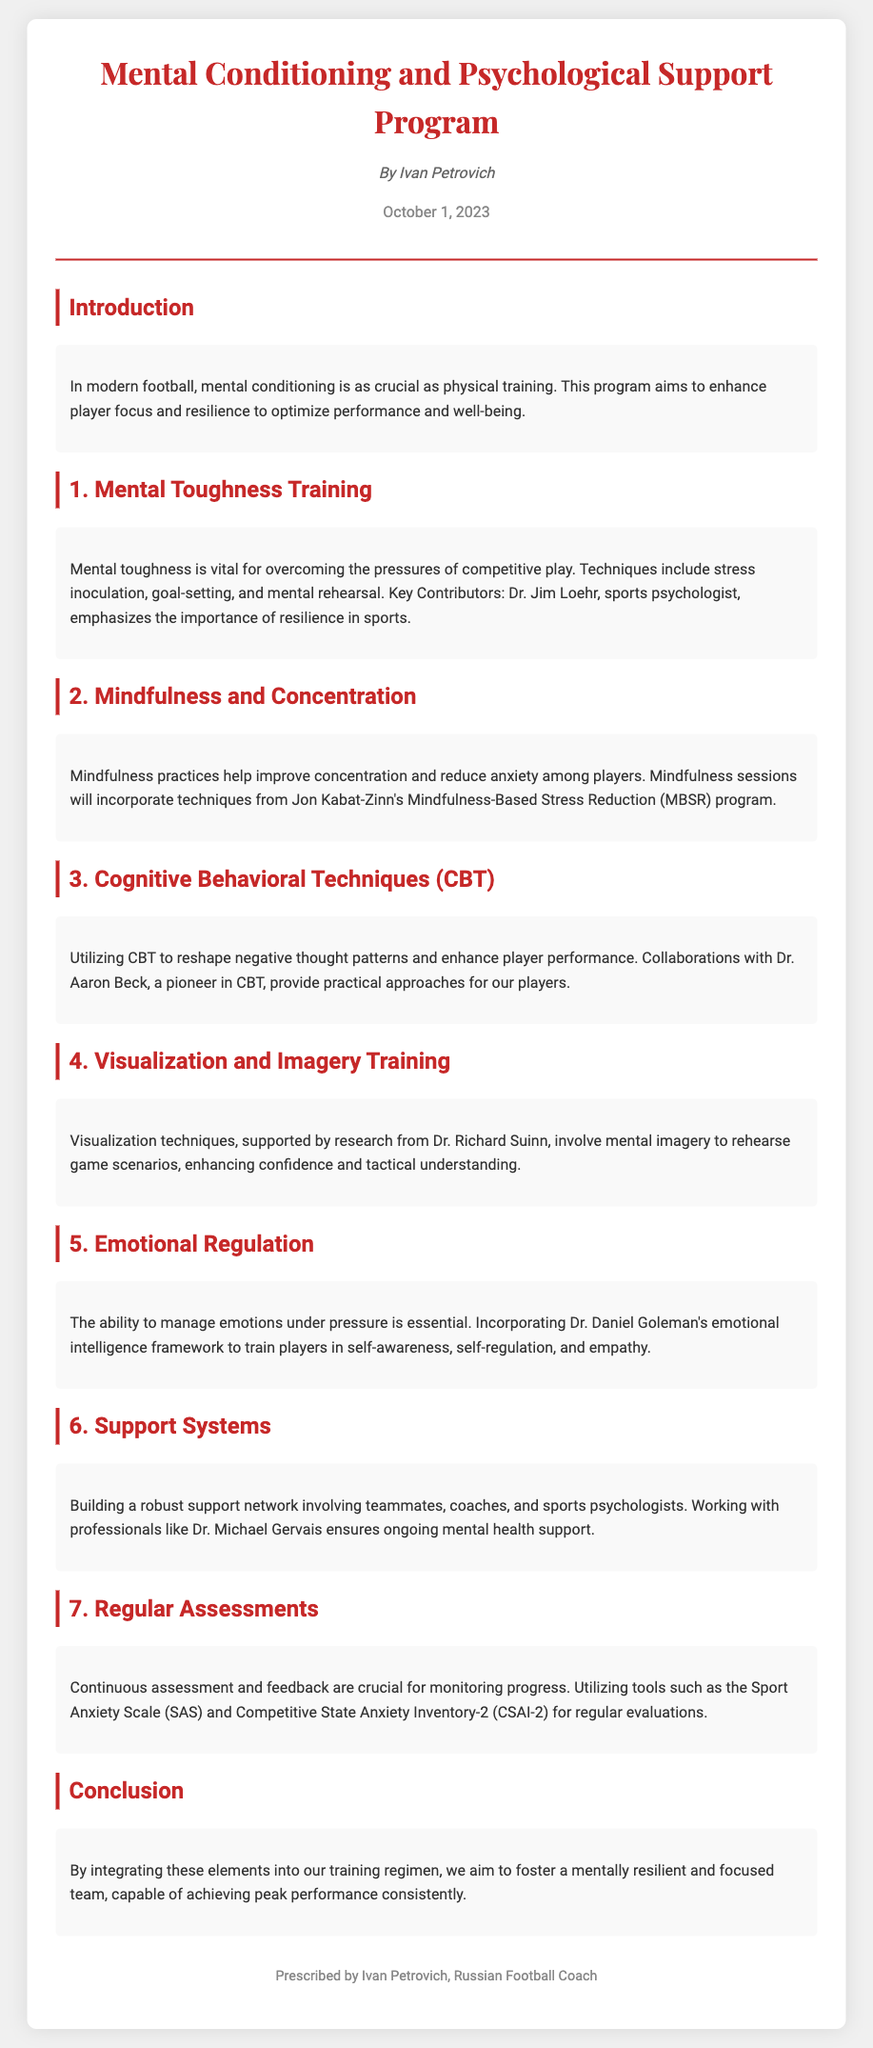what is the title of the program? The title of the program is mentioned at the top of the document.
Answer: Mental Conditioning and Psychological Support Program who is the author of the program? The author of the program is listed below the title.
Answer: Ivan Petrovich when was the program published? The date of publication is provided at the end of the author information.
Answer: October 1, 2023 what technique is included in the Mental Toughness Training section? The document specifies several techniques in the Mental Toughness Training section.
Answer: stress inoculation which framework is used for Emotional Regulation? The document references a specific framework related to Emotional Regulation.
Answer: Dr. Daniel Goleman's emotional intelligence framework what is emphasized in the Introduction section? The introduction highlights the importance of a specific aspect of football.
Answer: mental conditioning how is players' performance monitored? The document outlines a specific approach for assessing players’ performance.
Answer: Regular assessments who is mentioned as a collaborator for CBT techniques? The collaborator mentioned in the document provides insight into cognitive behavioral techniques.
Answer: Dr. Aaron Beck what type of training does the Visualization and Imagery Training section focus on? The section describes a particular type of training used to enhance player confidence.
Answer: mental imagery 